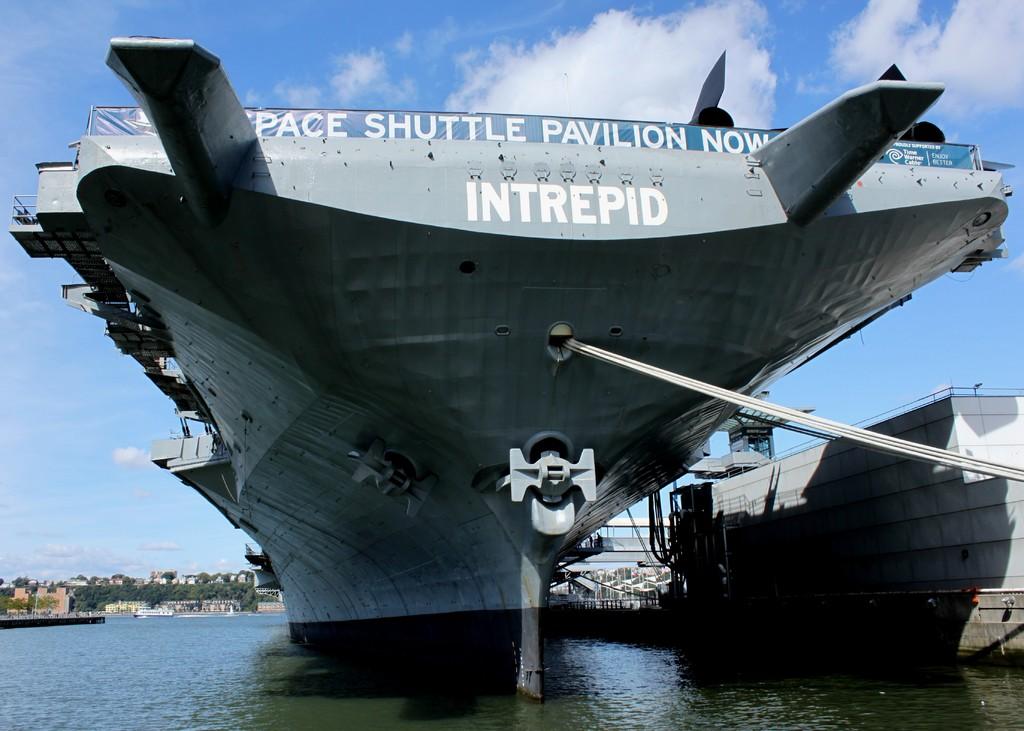What is the name on the transom of this ship?
Provide a short and direct response. Intrepid. 